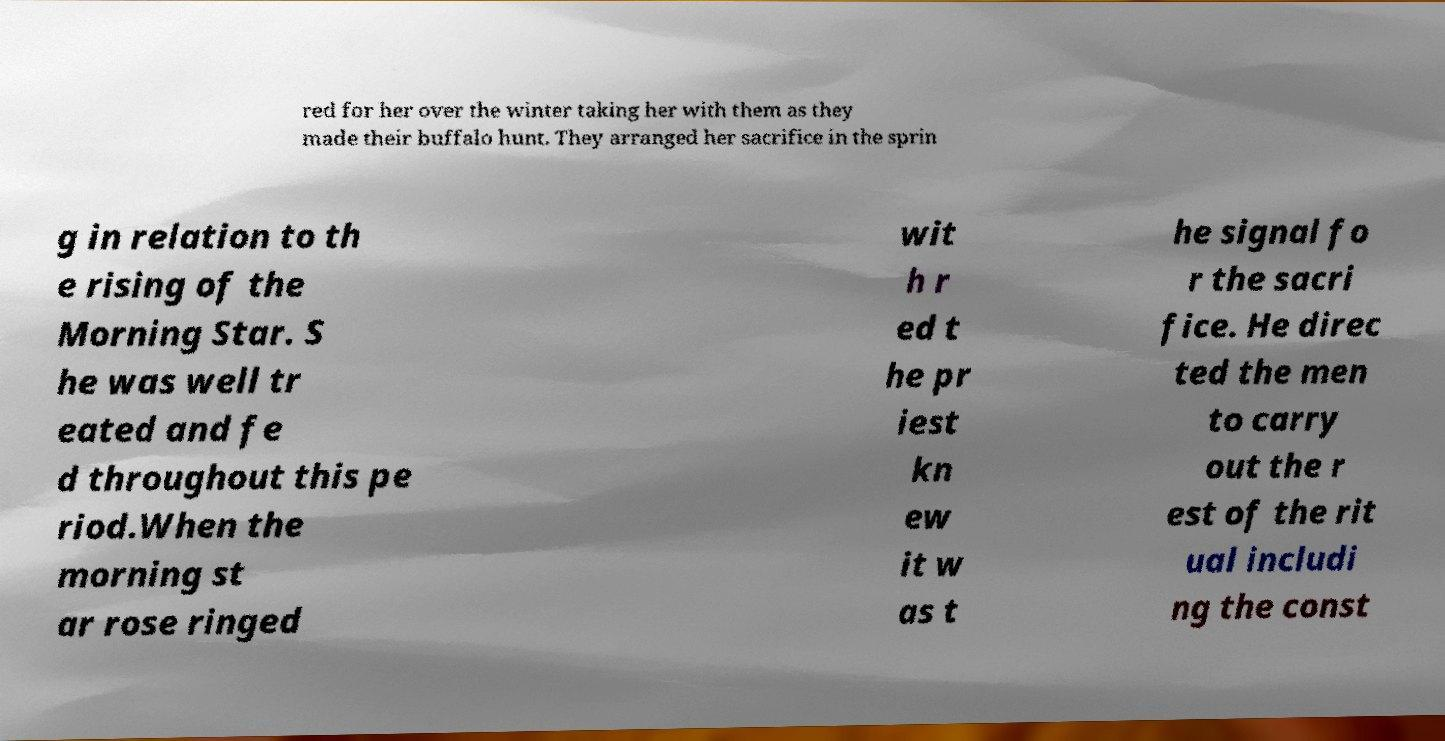Could you assist in decoding the text presented in this image and type it out clearly? red for her over the winter taking her with them as they made their buffalo hunt. They arranged her sacrifice in the sprin g in relation to th e rising of the Morning Star. S he was well tr eated and fe d throughout this pe riod.When the morning st ar rose ringed wit h r ed t he pr iest kn ew it w as t he signal fo r the sacri fice. He direc ted the men to carry out the r est of the rit ual includi ng the const 